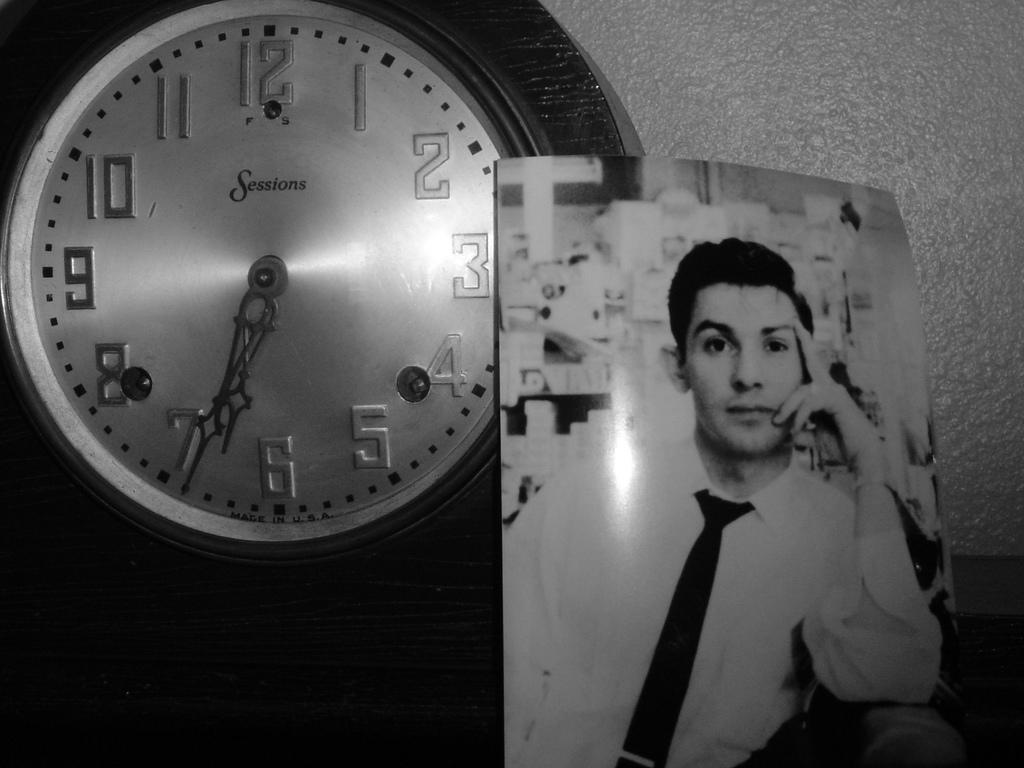Provide a one-sentence caption for the provided image. a black and white photo next to a clock with the time after 6:30. 